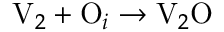Convert formula to latex. <formula><loc_0><loc_0><loc_500><loc_500>V _ { 2 } + O _ { i } \to V _ { 2 } O</formula> 